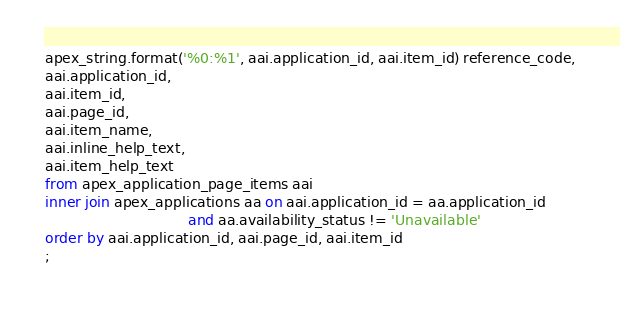<code> <loc_0><loc_0><loc_500><loc_500><_SQL_>apex_string.format('%0:%1', aai.application_id, aai.item_id) reference_code,
aai.application_id,
aai.item_id,
aai.page_id,
aai.item_name, 
aai.inline_help_text, 
aai.item_help_text
from apex_application_page_items aai
inner join apex_applications aa on aai.application_id = aa.application_id
                                and aa.availability_status != 'Unavailable'
order by aai.application_id, aai.page_id, aai.item_id 
;
    </code> 